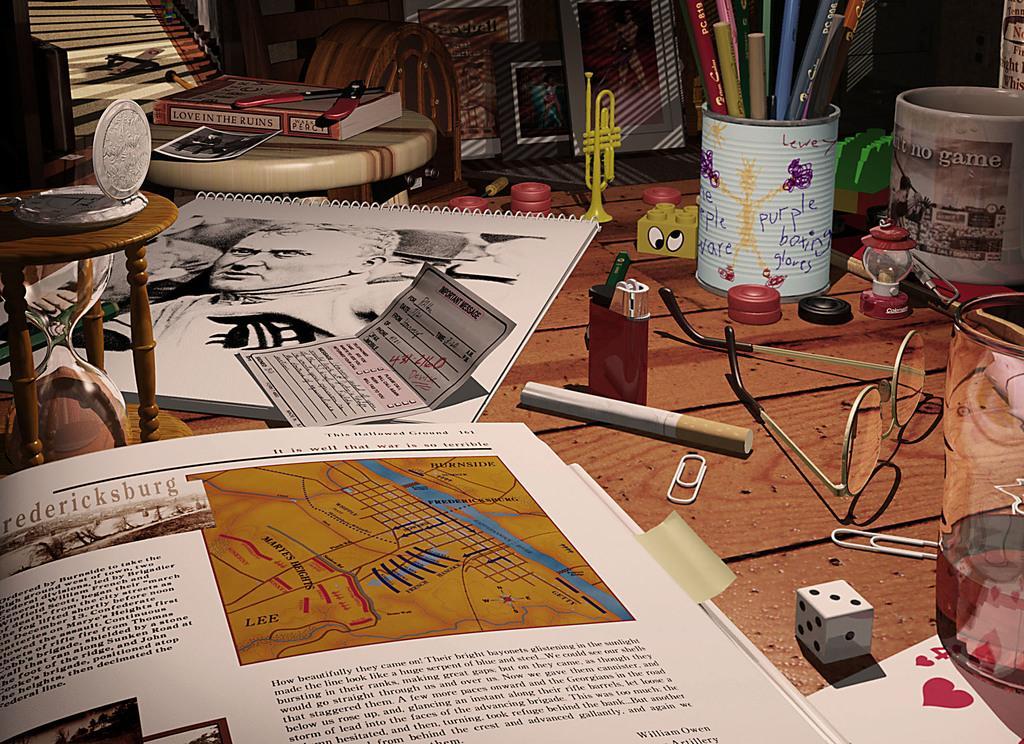Describe this image in one or two sentences. In this picture we can see table and on table we have so many items such as books, card, cigarette, lighter, spectacle , dice, cup, pens stand, pens, saxophone, knife. 